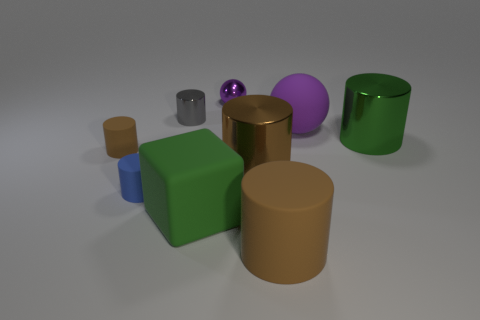Subtract all red cubes. How many brown cylinders are left? 3 Subtract 3 cylinders. How many cylinders are left? 3 Subtract all blue cylinders. How many cylinders are left? 5 Subtract all large brown cylinders. How many cylinders are left? 4 Subtract all red cylinders. Subtract all yellow spheres. How many cylinders are left? 6 Add 1 blue rubber cylinders. How many objects exist? 10 Subtract all balls. How many objects are left? 7 Add 5 gray cylinders. How many gray cylinders are left? 6 Add 8 tiny blue things. How many tiny blue things exist? 9 Subtract 1 gray cylinders. How many objects are left? 8 